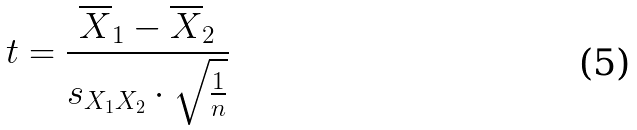<formula> <loc_0><loc_0><loc_500><loc_500>t = \frac { \overline { X } _ { 1 } - \overline { X } _ { 2 } } { s _ { X _ { 1 } X _ { 2 } } \cdot \sqrt { \frac { 1 } { n } } }</formula> 